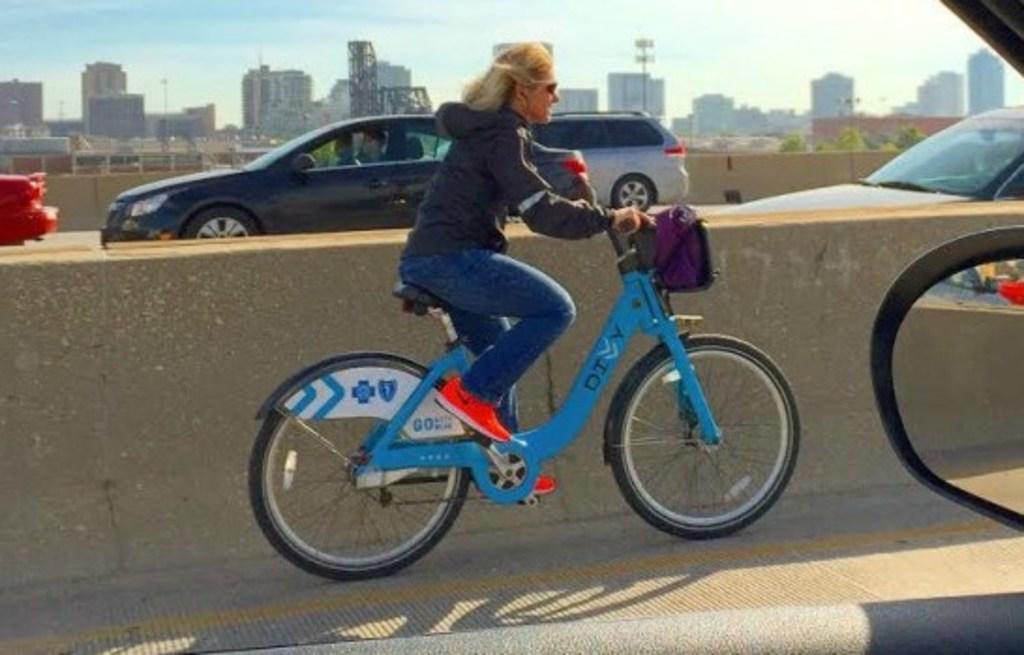How would you summarize this image in a sentence or two? In the center of the image we can see a person is riding bicycle. In the background of the image we can see the buildings, lights, poles, wall, vehicles. At the bottom of the image we can see the road. On the right side of the image we can see the plants. At the top of the image we can see the sky. 